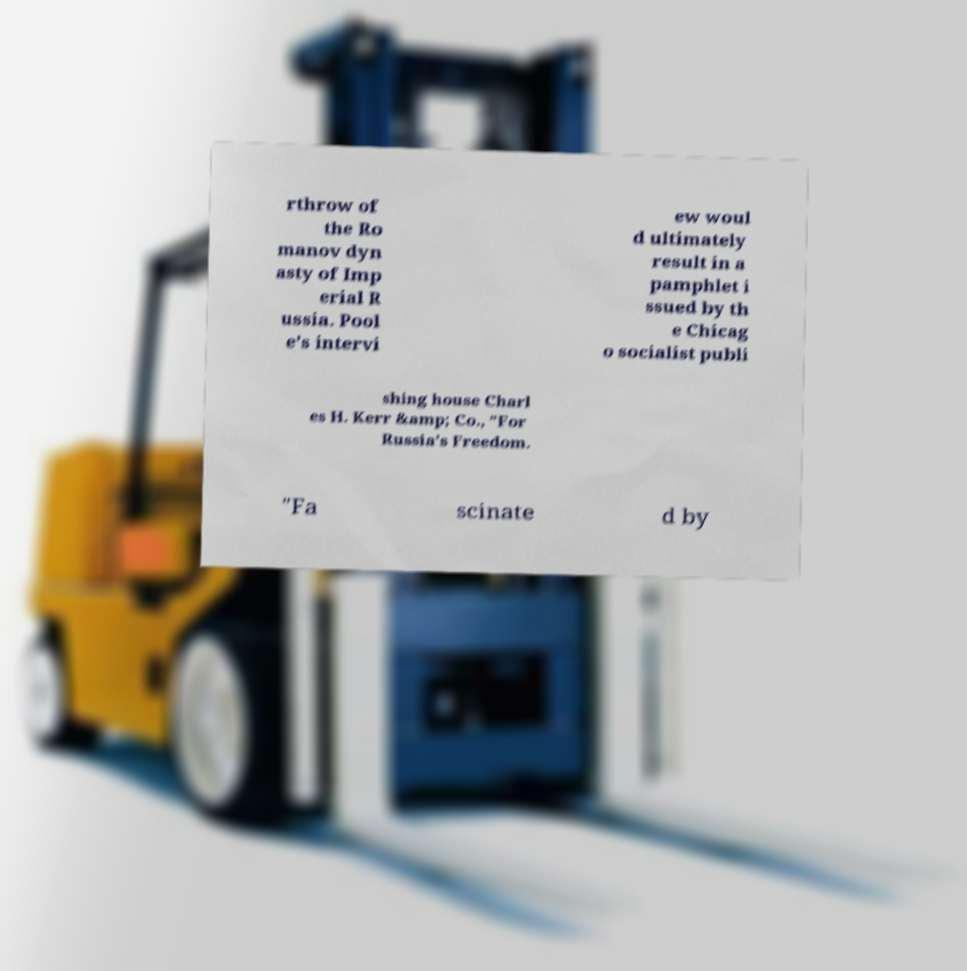Please identify and transcribe the text found in this image. rthrow of the Ro manov dyn asty of Imp erial R ussia. Pool e's intervi ew woul d ultimately result in a pamphlet i ssued by th e Chicag o socialist publi shing house Charl es H. Kerr &amp; Co., "For Russia's Freedom. "Fa scinate d by 